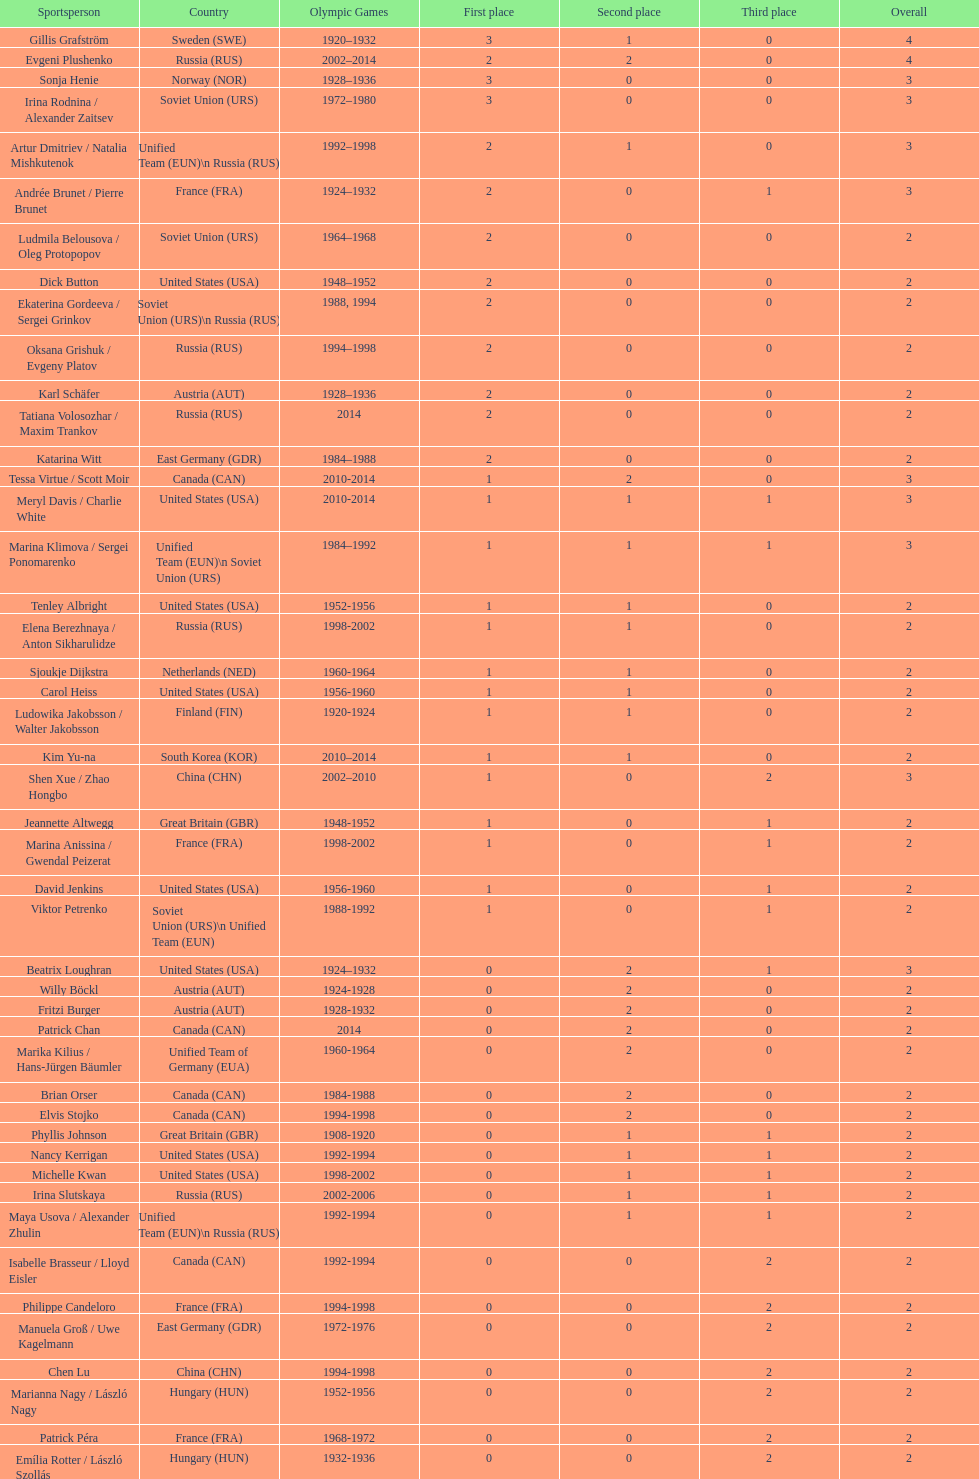What was the greatest number of gold medals won by a single athlete? 3. 